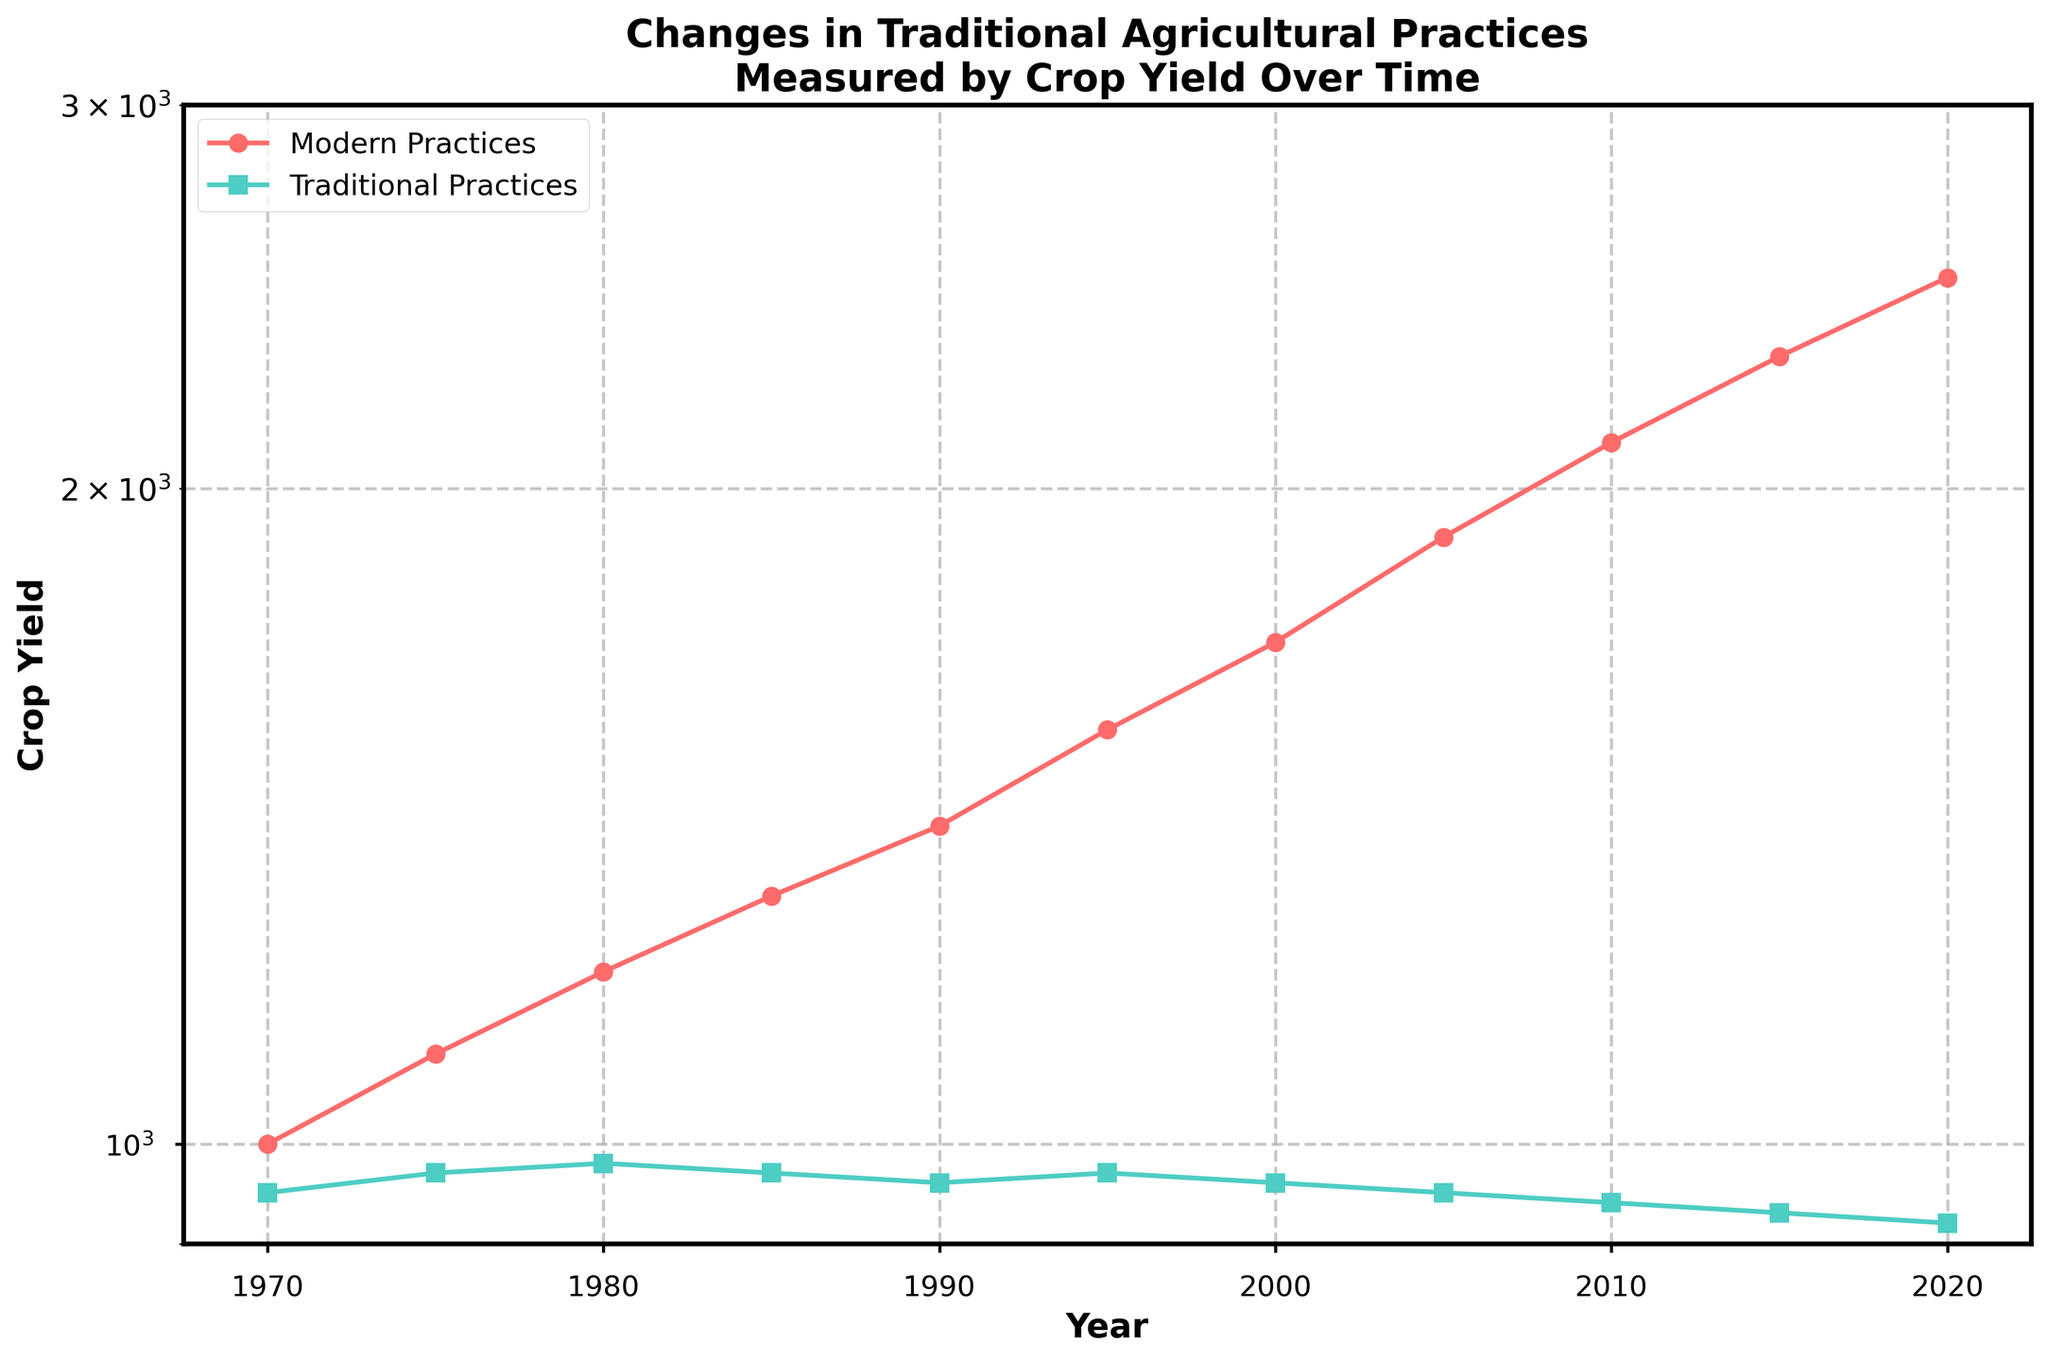What is the title of the plot? The title of the plot is prominently displayed at the top in bold font. It provides context for what the graph is depicting, which helps the viewer understand the purpose of the data visualization.
Answer: Changes in Traditional Agricultural Practices Measured by Crop Yield Over Time How many data points are plotted for each practice? Each practice has data points marked on the graph. You can count the markers on each line to determine how many data points there are for both modern practices and traditional practices. Both practice lines span the same number of data points.
Answer: 11 What is the y-axis scale used in the plot? The y-axis scale is indicated along the vertical axis, and it has a note that the scale is logarithmic. This scale is used to better visualize data that span several orders of magnitude.
Answer: Logarithmic In which year is the crop yield highest for modern practices? To find the year with the highest yield for modern practices, look for the data point on the red line that is positioned the highest on the y-scale. This point corresponds to the highest crop yield.
Answer: 2020 How does the crop yield trend over time for traditional practices? Observe the green line representing traditional practices across the years. The trend indicates whether the yield is increasing, decreasing, or remaining constant over time.
Answer: Decreasing Compute the difference in crop yield between modern and traditional practices in 2000. Locate the data points for the year 2000 on both lines. Subtract the crop yield for traditional practices from the crop yield for modern practices to find the difference.
Answer: 740 Which practice shows a more rapid increase in crop yield over time? Compare the slopes of the red and green lines. A steeper slope indicates a more rapid increase or decrease in yield over time.
Answer: Modern practices By what factor does the crop yield increase for modern practices from 1970 to 2020? Find the crop yields for modern practices in 1970 and 2020. Divide the yield in 2020 by the yield in 1970 to get the factor of increase.
Answer: 2.5 Is there any year where the crop yields for both practices are equal? Examine the plots and see if the red and green markers intersect at any point. Intersection signifies equal crop yields for both practices in that year.
Answer: No What inference can you draw about traditional practices from the plot? Analyze the trend and position of the green line over the years to make an inference about the effectiveness or changes in traditional agricultural practices.
Answer: Decreasing effectiveness 